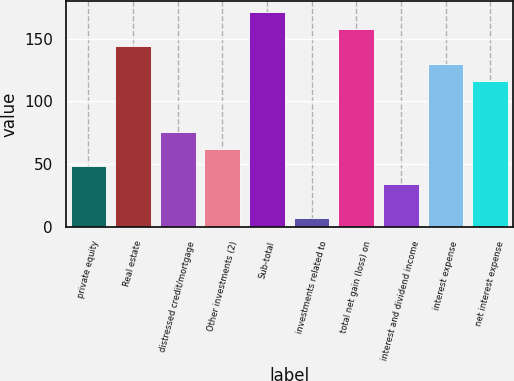Convert chart. <chart><loc_0><loc_0><loc_500><loc_500><bar_chart><fcel>private equity<fcel>Real estate<fcel>distressed credit/mortgage<fcel>Other investments (2)<fcel>Sub-total<fcel>investments related to<fcel>total net gain (loss) on<fcel>interest and dividend income<fcel>interest expense<fcel>net interest expense<nl><fcel>48.1<fcel>144<fcel>75.5<fcel>61.8<fcel>171.4<fcel>7<fcel>157.7<fcel>34.4<fcel>130.3<fcel>116.6<nl></chart> 